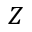Convert formula to latex. <formula><loc_0><loc_0><loc_500><loc_500>Z</formula> 